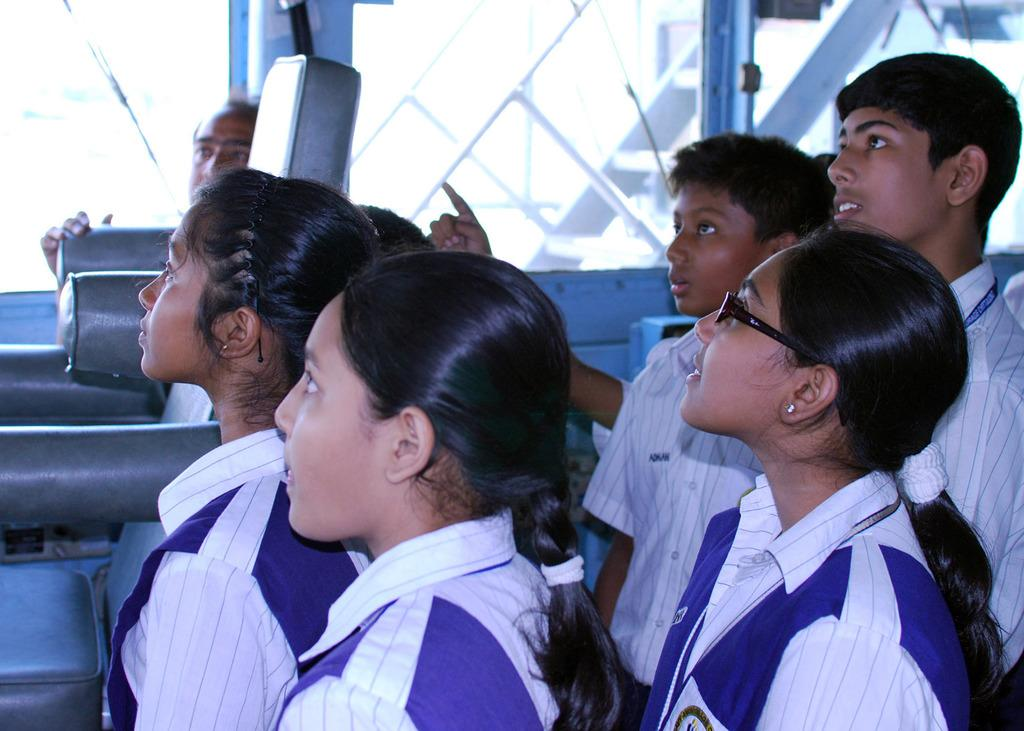What is the main subject of the image? The main subject of the image is a group of people standing. Can you describe any specific objects in the image? Yes, there is a glass object and a spectacle in the image. Are there any other objects present in the image that are not specified? Yes, there are some unspecified objects in the image. What type of farmer is distributing the vase in the image? There is no farmer or vase present in the image. 